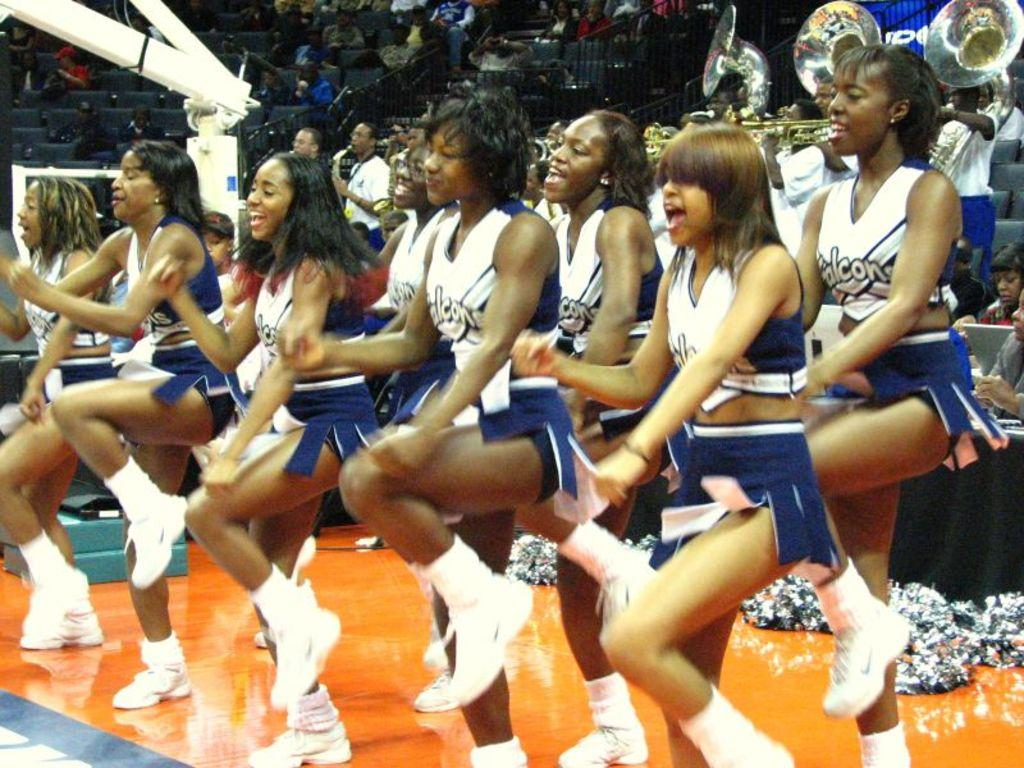<image>
Create a compact narrative representing the image presented. Cheer leaders wearing shirts which says Falcon on it. 